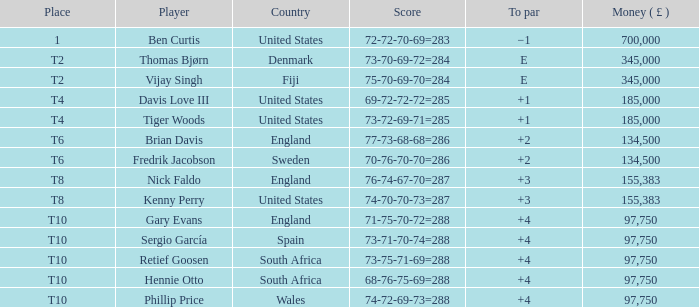What is fredrik jacobson's to par? 2.0. 